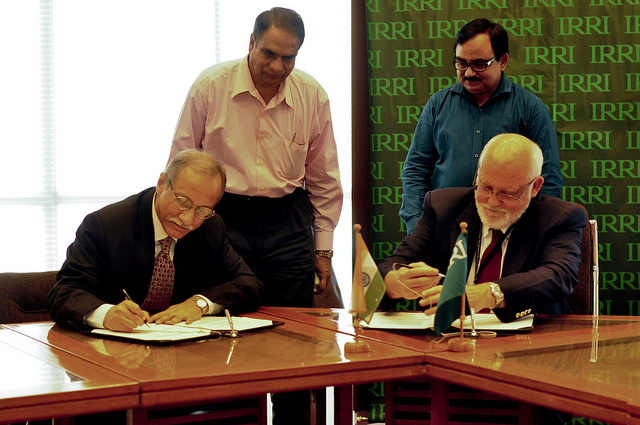How many men are sitting down? 2 